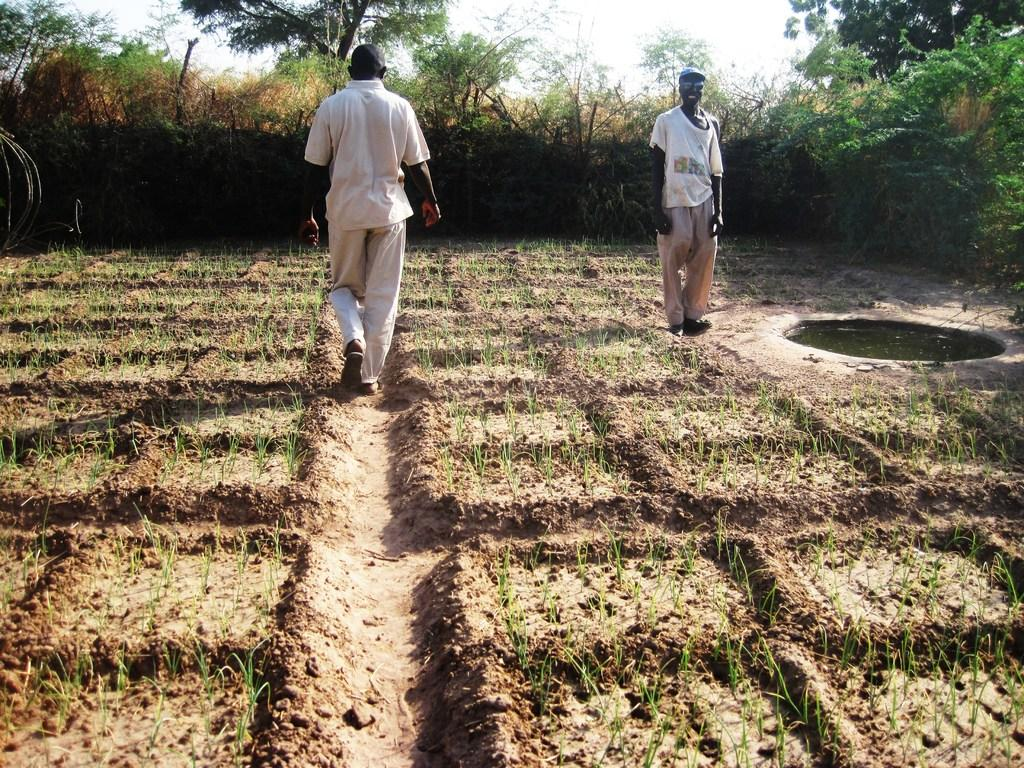How many people are in the image? There are two persons in the image. What type of vegetation can be seen in the image? There are crops, plants, and trees visible in the image. What natural element is visible in the image? Water and the sky are visible in the image. What type of clouds can be seen in the image? There is no mention of clouds in the provided facts, and therefore we cannot determine if any clouds are present in the image. 